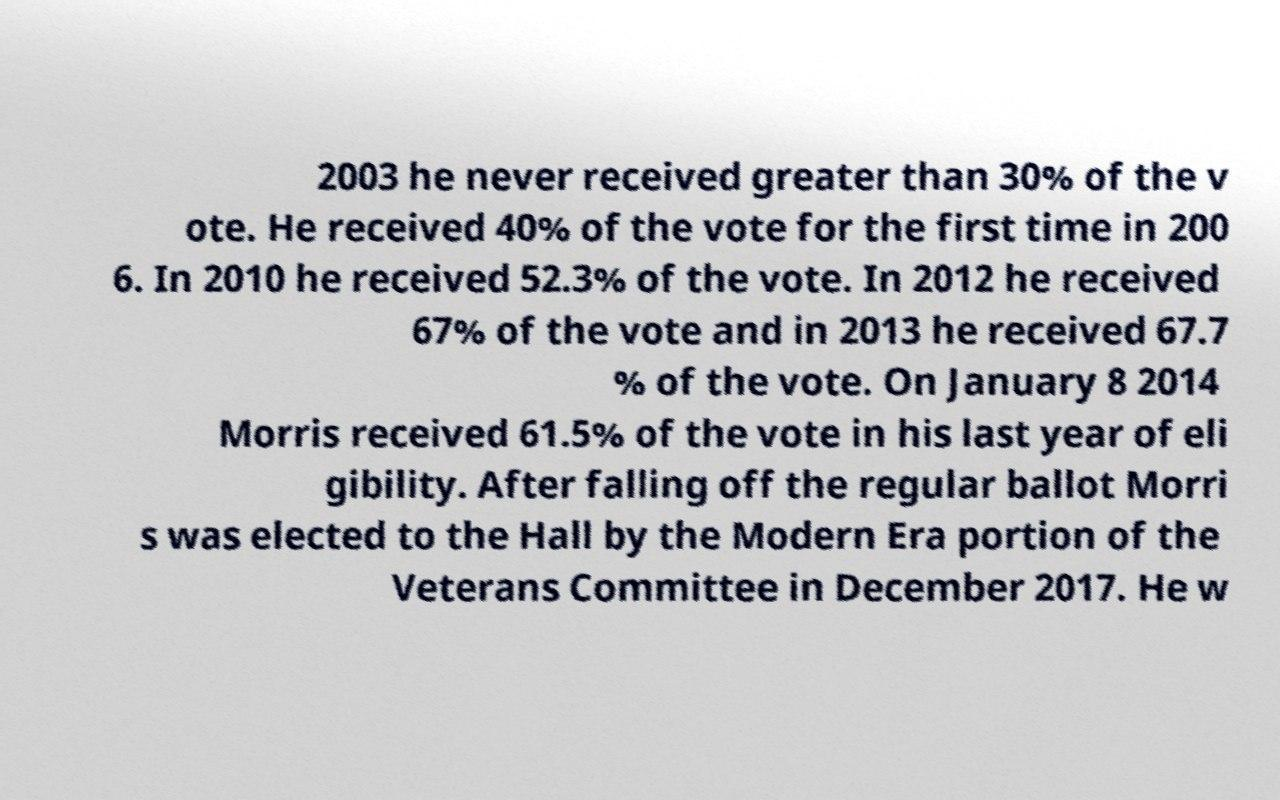Please identify and transcribe the text found in this image. 2003 he never received greater than 30% of the v ote. He received 40% of the vote for the first time in 200 6. In 2010 he received 52.3% of the vote. In 2012 he received 67% of the vote and in 2013 he received 67.7 % of the vote. On January 8 2014 Morris received 61.5% of the vote in his last year of eli gibility. After falling off the regular ballot Morri s was elected to the Hall by the Modern Era portion of the Veterans Committee in December 2017. He w 